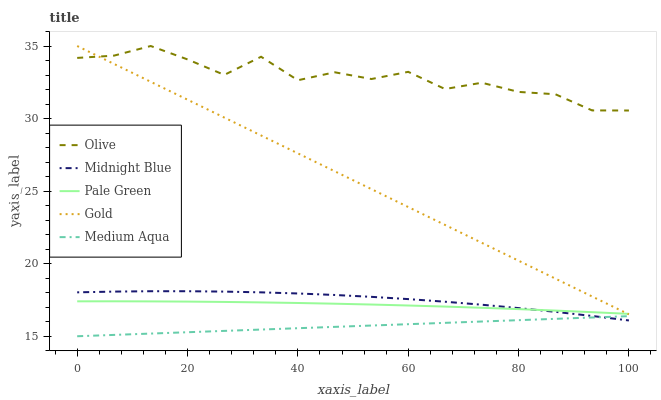Does Medium Aqua have the minimum area under the curve?
Answer yes or no. Yes. Does Olive have the maximum area under the curve?
Answer yes or no. Yes. Does Pale Green have the minimum area under the curve?
Answer yes or no. No. Does Pale Green have the maximum area under the curve?
Answer yes or no. No. Is Medium Aqua the smoothest?
Answer yes or no. Yes. Is Olive the roughest?
Answer yes or no. Yes. Is Pale Green the smoothest?
Answer yes or no. No. Is Pale Green the roughest?
Answer yes or no. No. Does Medium Aqua have the lowest value?
Answer yes or no. Yes. Does Pale Green have the lowest value?
Answer yes or no. No. Does Gold have the highest value?
Answer yes or no. Yes. Does Pale Green have the highest value?
Answer yes or no. No. Is Midnight Blue less than Olive?
Answer yes or no. Yes. Is Olive greater than Medium Aqua?
Answer yes or no. Yes. Does Olive intersect Gold?
Answer yes or no. Yes. Is Olive less than Gold?
Answer yes or no. No. Is Olive greater than Gold?
Answer yes or no. No. Does Midnight Blue intersect Olive?
Answer yes or no. No. 